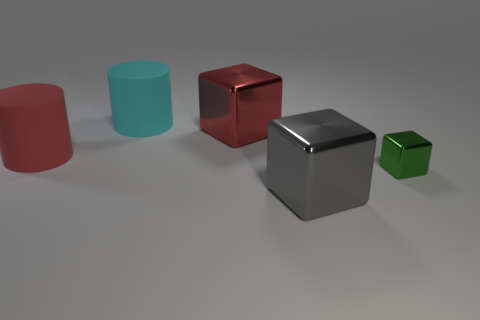Are there the same number of big matte things that are in front of the green block and gray shiny cubes to the left of the cyan matte object?
Keep it short and to the point. Yes. What is the shape of the red object to the right of the cyan cylinder that is on the left side of the red metal object?
Give a very brief answer. Cube. There is a large red thing that is the same shape as the large gray shiny object; what is it made of?
Your answer should be very brief. Metal. The metallic object that is the same size as the gray cube is what color?
Your response must be concise. Red. Are there an equal number of green objects behind the gray cube and small cyan rubber blocks?
Your answer should be compact. No. What is the color of the metal object that is on the left side of the big shiny object in front of the green block?
Offer a very short reply. Red. There is a shiny cube behind the red object that is left of the red metal cube; what size is it?
Keep it short and to the point. Large. What number of other things are the same size as the red rubber cylinder?
Ensure brevity in your answer.  3. What color is the thing on the right side of the big thing that is in front of the cylinder that is on the left side of the big cyan matte cylinder?
Your response must be concise. Green. How many other objects are the same shape as the gray object?
Provide a short and direct response. 2. 